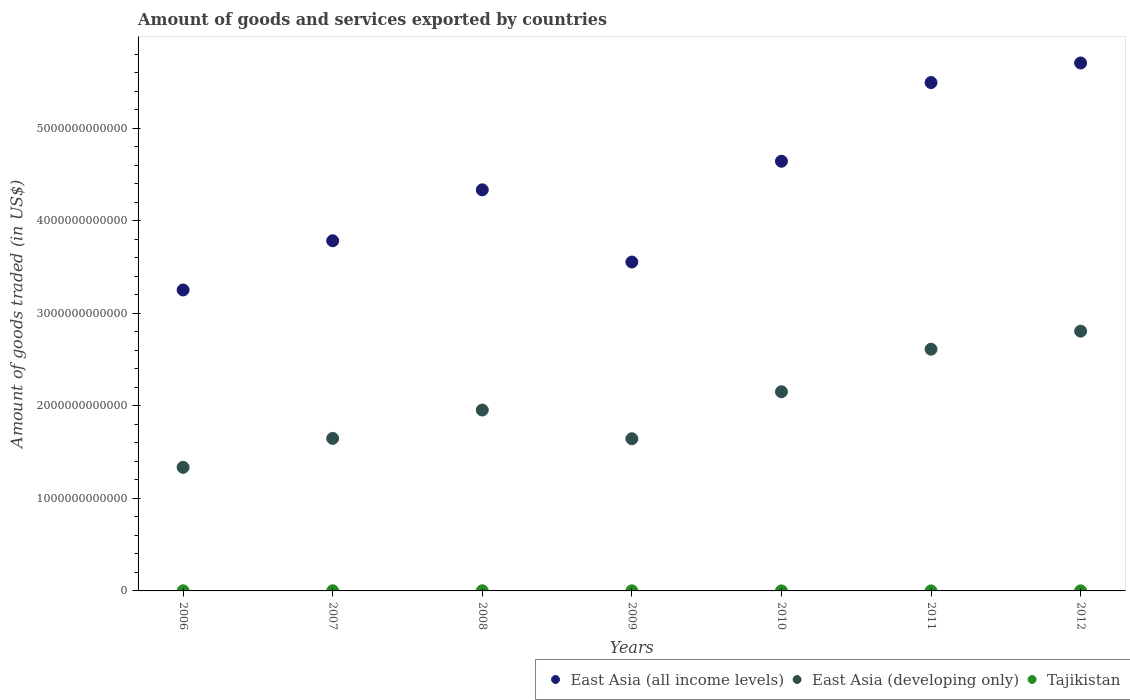What is the total amount of goods and services exported in Tajikistan in 2006?
Your answer should be very brief. 1.51e+09. Across all years, what is the maximum total amount of goods and services exported in East Asia (developing only)?
Offer a terse response. 2.81e+12. Across all years, what is the minimum total amount of goods and services exported in East Asia (developing only)?
Give a very brief answer. 1.34e+12. In which year was the total amount of goods and services exported in Tajikistan maximum?
Offer a very short reply. 2008. What is the total total amount of goods and services exported in East Asia (all income levels) in the graph?
Your response must be concise. 3.08e+13. What is the difference between the total amount of goods and services exported in Tajikistan in 2007 and that in 2012?
Keep it short and to the point. 7.31e+08. What is the difference between the total amount of goods and services exported in East Asia (all income levels) in 2006 and the total amount of goods and services exported in East Asia (developing only) in 2009?
Keep it short and to the point. 1.61e+12. What is the average total amount of goods and services exported in Tajikistan per year?
Your answer should be compact. 1.08e+09. In the year 2007, what is the difference between the total amount of goods and services exported in East Asia (developing only) and total amount of goods and services exported in Tajikistan?
Keep it short and to the point. 1.65e+12. In how many years, is the total amount of goods and services exported in East Asia (all income levels) greater than 5200000000000 US$?
Provide a succinct answer. 2. What is the ratio of the total amount of goods and services exported in East Asia (developing only) in 2008 to that in 2012?
Provide a succinct answer. 0.7. What is the difference between the highest and the second highest total amount of goods and services exported in Tajikistan?
Your response must be concise. 1.80e+07. What is the difference between the highest and the lowest total amount of goods and services exported in East Asia (all income levels)?
Offer a very short reply. 2.45e+12. Is the total amount of goods and services exported in East Asia (all income levels) strictly less than the total amount of goods and services exported in East Asia (developing only) over the years?
Keep it short and to the point. No. How many dotlines are there?
Your answer should be very brief. 3. How many years are there in the graph?
Your response must be concise. 7. What is the difference between two consecutive major ticks on the Y-axis?
Make the answer very short. 1.00e+12. Are the values on the major ticks of Y-axis written in scientific E-notation?
Your response must be concise. No. Does the graph contain any zero values?
Your answer should be very brief. No. Where does the legend appear in the graph?
Ensure brevity in your answer.  Bottom right. How are the legend labels stacked?
Offer a very short reply. Horizontal. What is the title of the graph?
Your answer should be compact. Amount of goods and services exported by countries. What is the label or title of the X-axis?
Offer a very short reply. Years. What is the label or title of the Y-axis?
Your answer should be very brief. Amount of goods traded (in US$). What is the Amount of goods traded (in US$) of East Asia (all income levels) in 2006?
Your answer should be compact. 3.25e+12. What is the Amount of goods traded (in US$) in East Asia (developing only) in 2006?
Ensure brevity in your answer.  1.34e+12. What is the Amount of goods traded (in US$) of Tajikistan in 2006?
Your response must be concise. 1.51e+09. What is the Amount of goods traded (in US$) of East Asia (all income levels) in 2007?
Your response must be concise. 3.78e+12. What is the Amount of goods traded (in US$) in East Asia (developing only) in 2007?
Ensure brevity in your answer.  1.65e+12. What is the Amount of goods traded (in US$) in Tajikistan in 2007?
Offer a terse response. 1.56e+09. What is the Amount of goods traded (in US$) in East Asia (all income levels) in 2008?
Your answer should be compact. 4.33e+12. What is the Amount of goods traded (in US$) of East Asia (developing only) in 2008?
Provide a succinct answer. 1.95e+12. What is the Amount of goods traded (in US$) of Tajikistan in 2008?
Keep it short and to the point. 1.57e+09. What is the Amount of goods traded (in US$) in East Asia (all income levels) in 2009?
Offer a very short reply. 3.55e+12. What is the Amount of goods traded (in US$) of East Asia (developing only) in 2009?
Your response must be concise. 1.64e+12. What is the Amount of goods traded (in US$) of Tajikistan in 2009?
Offer a very short reply. 1.04e+09. What is the Amount of goods traded (in US$) in East Asia (all income levels) in 2010?
Give a very brief answer. 4.64e+12. What is the Amount of goods traded (in US$) of East Asia (developing only) in 2010?
Offer a very short reply. 2.15e+12. What is the Amount of goods traded (in US$) in Tajikistan in 2010?
Keep it short and to the point. 4.59e+08. What is the Amount of goods traded (in US$) in East Asia (all income levels) in 2011?
Provide a succinct answer. 5.49e+12. What is the Amount of goods traded (in US$) in East Asia (developing only) in 2011?
Ensure brevity in your answer.  2.61e+12. What is the Amount of goods traded (in US$) of Tajikistan in 2011?
Make the answer very short. 5.93e+08. What is the Amount of goods traded (in US$) in East Asia (all income levels) in 2012?
Offer a very short reply. 5.70e+12. What is the Amount of goods traded (in US$) of East Asia (developing only) in 2012?
Ensure brevity in your answer.  2.81e+12. What is the Amount of goods traded (in US$) of Tajikistan in 2012?
Your answer should be compact. 8.26e+08. Across all years, what is the maximum Amount of goods traded (in US$) of East Asia (all income levels)?
Offer a terse response. 5.70e+12. Across all years, what is the maximum Amount of goods traded (in US$) in East Asia (developing only)?
Make the answer very short. 2.81e+12. Across all years, what is the maximum Amount of goods traded (in US$) of Tajikistan?
Ensure brevity in your answer.  1.57e+09. Across all years, what is the minimum Amount of goods traded (in US$) of East Asia (all income levels)?
Offer a very short reply. 3.25e+12. Across all years, what is the minimum Amount of goods traded (in US$) in East Asia (developing only)?
Make the answer very short. 1.34e+12. Across all years, what is the minimum Amount of goods traded (in US$) in Tajikistan?
Your answer should be very brief. 4.59e+08. What is the total Amount of goods traded (in US$) in East Asia (all income levels) in the graph?
Your response must be concise. 3.08e+13. What is the total Amount of goods traded (in US$) of East Asia (developing only) in the graph?
Provide a succinct answer. 1.42e+13. What is the total Amount of goods traded (in US$) in Tajikistan in the graph?
Give a very brief answer. 7.56e+09. What is the difference between the Amount of goods traded (in US$) of East Asia (all income levels) in 2006 and that in 2007?
Your response must be concise. -5.32e+11. What is the difference between the Amount of goods traded (in US$) of East Asia (developing only) in 2006 and that in 2007?
Offer a terse response. -3.13e+11. What is the difference between the Amount of goods traded (in US$) in Tajikistan in 2006 and that in 2007?
Provide a succinct answer. -4.51e+07. What is the difference between the Amount of goods traded (in US$) in East Asia (all income levels) in 2006 and that in 2008?
Your answer should be compact. -1.08e+12. What is the difference between the Amount of goods traded (in US$) of East Asia (developing only) in 2006 and that in 2008?
Your answer should be compact. -6.19e+11. What is the difference between the Amount of goods traded (in US$) in Tajikistan in 2006 and that in 2008?
Offer a terse response. -6.31e+07. What is the difference between the Amount of goods traded (in US$) in East Asia (all income levels) in 2006 and that in 2009?
Ensure brevity in your answer.  -3.02e+11. What is the difference between the Amount of goods traded (in US$) in East Asia (developing only) in 2006 and that in 2009?
Ensure brevity in your answer.  -3.09e+11. What is the difference between the Amount of goods traded (in US$) of Tajikistan in 2006 and that in 2009?
Ensure brevity in your answer.  4.73e+08. What is the difference between the Amount of goods traded (in US$) of East Asia (all income levels) in 2006 and that in 2010?
Offer a very short reply. -1.39e+12. What is the difference between the Amount of goods traded (in US$) of East Asia (developing only) in 2006 and that in 2010?
Keep it short and to the point. -8.17e+11. What is the difference between the Amount of goods traded (in US$) of Tajikistan in 2006 and that in 2010?
Keep it short and to the point. 1.05e+09. What is the difference between the Amount of goods traded (in US$) of East Asia (all income levels) in 2006 and that in 2011?
Give a very brief answer. -2.24e+12. What is the difference between the Amount of goods traded (in US$) in East Asia (developing only) in 2006 and that in 2011?
Provide a succinct answer. -1.28e+12. What is the difference between the Amount of goods traded (in US$) in Tajikistan in 2006 and that in 2011?
Offer a terse response. 9.18e+08. What is the difference between the Amount of goods traded (in US$) in East Asia (all income levels) in 2006 and that in 2012?
Give a very brief answer. -2.45e+12. What is the difference between the Amount of goods traded (in US$) of East Asia (developing only) in 2006 and that in 2012?
Make the answer very short. -1.47e+12. What is the difference between the Amount of goods traded (in US$) in Tajikistan in 2006 and that in 2012?
Ensure brevity in your answer.  6.86e+08. What is the difference between the Amount of goods traded (in US$) in East Asia (all income levels) in 2007 and that in 2008?
Your answer should be compact. -5.50e+11. What is the difference between the Amount of goods traded (in US$) of East Asia (developing only) in 2007 and that in 2008?
Give a very brief answer. -3.07e+11. What is the difference between the Amount of goods traded (in US$) in Tajikistan in 2007 and that in 2008?
Ensure brevity in your answer.  -1.80e+07. What is the difference between the Amount of goods traded (in US$) of East Asia (all income levels) in 2007 and that in 2009?
Your response must be concise. 2.30e+11. What is the difference between the Amount of goods traded (in US$) in East Asia (developing only) in 2007 and that in 2009?
Keep it short and to the point. 3.78e+09. What is the difference between the Amount of goods traded (in US$) of Tajikistan in 2007 and that in 2009?
Ensure brevity in your answer.  5.18e+08. What is the difference between the Amount of goods traded (in US$) of East Asia (all income levels) in 2007 and that in 2010?
Ensure brevity in your answer.  -8.59e+11. What is the difference between the Amount of goods traded (in US$) of East Asia (developing only) in 2007 and that in 2010?
Your answer should be very brief. -5.04e+11. What is the difference between the Amount of goods traded (in US$) of Tajikistan in 2007 and that in 2010?
Ensure brevity in your answer.  1.10e+09. What is the difference between the Amount of goods traded (in US$) of East Asia (all income levels) in 2007 and that in 2011?
Your answer should be very brief. -1.71e+12. What is the difference between the Amount of goods traded (in US$) of East Asia (developing only) in 2007 and that in 2011?
Your answer should be compact. -9.64e+11. What is the difference between the Amount of goods traded (in US$) in Tajikistan in 2007 and that in 2011?
Give a very brief answer. 9.64e+08. What is the difference between the Amount of goods traded (in US$) of East Asia (all income levels) in 2007 and that in 2012?
Give a very brief answer. -1.92e+12. What is the difference between the Amount of goods traded (in US$) of East Asia (developing only) in 2007 and that in 2012?
Offer a very short reply. -1.16e+12. What is the difference between the Amount of goods traded (in US$) in Tajikistan in 2007 and that in 2012?
Offer a very short reply. 7.31e+08. What is the difference between the Amount of goods traded (in US$) in East Asia (all income levels) in 2008 and that in 2009?
Keep it short and to the point. 7.80e+11. What is the difference between the Amount of goods traded (in US$) in East Asia (developing only) in 2008 and that in 2009?
Provide a succinct answer. 3.10e+11. What is the difference between the Amount of goods traded (in US$) in Tajikistan in 2008 and that in 2009?
Keep it short and to the point. 5.36e+08. What is the difference between the Amount of goods traded (in US$) in East Asia (all income levels) in 2008 and that in 2010?
Provide a short and direct response. -3.09e+11. What is the difference between the Amount of goods traded (in US$) in East Asia (developing only) in 2008 and that in 2010?
Offer a terse response. -1.98e+11. What is the difference between the Amount of goods traded (in US$) of Tajikistan in 2008 and that in 2010?
Give a very brief answer. 1.12e+09. What is the difference between the Amount of goods traded (in US$) of East Asia (all income levels) in 2008 and that in 2011?
Provide a short and direct response. -1.16e+12. What is the difference between the Amount of goods traded (in US$) of East Asia (developing only) in 2008 and that in 2011?
Keep it short and to the point. -6.57e+11. What is the difference between the Amount of goods traded (in US$) of Tajikistan in 2008 and that in 2011?
Ensure brevity in your answer.  9.82e+08. What is the difference between the Amount of goods traded (in US$) of East Asia (all income levels) in 2008 and that in 2012?
Make the answer very short. -1.37e+12. What is the difference between the Amount of goods traded (in US$) of East Asia (developing only) in 2008 and that in 2012?
Ensure brevity in your answer.  -8.52e+11. What is the difference between the Amount of goods traded (in US$) of Tajikistan in 2008 and that in 2012?
Your answer should be compact. 7.49e+08. What is the difference between the Amount of goods traded (in US$) of East Asia (all income levels) in 2009 and that in 2010?
Keep it short and to the point. -1.09e+12. What is the difference between the Amount of goods traded (in US$) in East Asia (developing only) in 2009 and that in 2010?
Make the answer very short. -5.08e+11. What is the difference between the Amount of goods traded (in US$) of Tajikistan in 2009 and that in 2010?
Offer a very short reply. 5.79e+08. What is the difference between the Amount of goods traded (in US$) of East Asia (all income levels) in 2009 and that in 2011?
Keep it short and to the point. -1.94e+12. What is the difference between the Amount of goods traded (in US$) in East Asia (developing only) in 2009 and that in 2011?
Make the answer very short. -9.68e+11. What is the difference between the Amount of goods traded (in US$) of Tajikistan in 2009 and that in 2011?
Your response must be concise. 4.45e+08. What is the difference between the Amount of goods traded (in US$) of East Asia (all income levels) in 2009 and that in 2012?
Offer a very short reply. -2.15e+12. What is the difference between the Amount of goods traded (in US$) of East Asia (developing only) in 2009 and that in 2012?
Offer a very short reply. -1.16e+12. What is the difference between the Amount of goods traded (in US$) in Tajikistan in 2009 and that in 2012?
Provide a succinct answer. 2.13e+08. What is the difference between the Amount of goods traded (in US$) in East Asia (all income levels) in 2010 and that in 2011?
Make the answer very short. -8.50e+11. What is the difference between the Amount of goods traded (in US$) of East Asia (developing only) in 2010 and that in 2011?
Your answer should be very brief. -4.60e+11. What is the difference between the Amount of goods traded (in US$) of Tajikistan in 2010 and that in 2011?
Offer a very short reply. -1.34e+08. What is the difference between the Amount of goods traded (in US$) in East Asia (all income levels) in 2010 and that in 2012?
Your answer should be compact. -1.06e+12. What is the difference between the Amount of goods traded (in US$) in East Asia (developing only) in 2010 and that in 2012?
Provide a succinct answer. -6.55e+11. What is the difference between the Amount of goods traded (in US$) of Tajikistan in 2010 and that in 2012?
Ensure brevity in your answer.  -3.67e+08. What is the difference between the Amount of goods traded (in US$) of East Asia (all income levels) in 2011 and that in 2012?
Your answer should be compact. -2.12e+11. What is the difference between the Amount of goods traded (in US$) in East Asia (developing only) in 2011 and that in 2012?
Give a very brief answer. -1.95e+11. What is the difference between the Amount of goods traded (in US$) in Tajikistan in 2011 and that in 2012?
Offer a terse response. -2.33e+08. What is the difference between the Amount of goods traded (in US$) in East Asia (all income levels) in 2006 and the Amount of goods traded (in US$) in East Asia (developing only) in 2007?
Your response must be concise. 1.60e+12. What is the difference between the Amount of goods traded (in US$) in East Asia (all income levels) in 2006 and the Amount of goods traded (in US$) in Tajikistan in 2007?
Keep it short and to the point. 3.25e+12. What is the difference between the Amount of goods traded (in US$) in East Asia (developing only) in 2006 and the Amount of goods traded (in US$) in Tajikistan in 2007?
Ensure brevity in your answer.  1.33e+12. What is the difference between the Amount of goods traded (in US$) in East Asia (all income levels) in 2006 and the Amount of goods traded (in US$) in East Asia (developing only) in 2008?
Offer a terse response. 1.30e+12. What is the difference between the Amount of goods traded (in US$) of East Asia (all income levels) in 2006 and the Amount of goods traded (in US$) of Tajikistan in 2008?
Offer a very short reply. 3.25e+12. What is the difference between the Amount of goods traded (in US$) in East Asia (developing only) in 2006 and the Amount of goods traded (in US$) in Tajikistan in 2008?
Offer a very short reply. 1.33e+12. What is the difference between the Amount of goods traded (in US$) of East Asia (all income levels) in 2006 and the Amount of goods traded (in US$) of East Asia (developing only) in 2009?
Your answer should be very brief. 1.61e+12. What is the difference between the Amount of goods traded (in US$) of East Asia (all income levels) in 2006 and the Amount of goods traded (in US$) of Tajikistan in 2009?
Make the answer very short. 3.25e+12. What is the difference between the Amount of goods traded (in US$) in East Asia (developing only) in 2006 and the Amount of goods traded (in US$) in Tajikistan in 2009?
Make the answer very short. 1.33e+12. What is the difference between the Amount of goods traded (in US$) of East Asia (all income levels) in 2006 and the Amount of goods traded (in US$) of East Asia (developing only) in 2010?
Provide a succinct answer. 1.10e+12. What is the difference between the Amount of goods traded (in US$) in East Asia (all income levels) in 2006 and the Amount of goods traded (in US$) in Tajikistan in 2010?
Make the answer very short. 3.25e+12. What is the difference between the Amount of goods traded (in US$) of East Asia (developing only) in 2006 and the Amount of goods traded (in US$) of Tajikistan in 2010?
Keep it short and to the point. 1.33e+12. What is the difference between the Amount of goods traded (in US$) in East Asia (all income levels) in 2006 and the Amount of goods traded (in US$) in East Asia (developing only) in 2011?
Provide a succinct answer. 6.40e+11. What is the difference between the Amount of goods traded (in US$) in East Asia (all income levels) in 2006 and the Amount of goods traded (in US$) in Tajikistan in 2011?
Your answer should be very brief. 3.25e+12. What is the difference between the Amount of goods traded (in US$) in East Asia (developing only) in 2006 and the Amount of goods traded (in US$) in Tajikistan in 2011?
Offer a very short reply. 1.33e+12. What is the difference between the Amount of goods traded (in US$) of East Asia (all income levels) in 2006 and the Amount of goods traded (in US$) of East Asia (developing only) in 2012?
Your answer should be very brief. 4.45e+11. What is the difference between the Amount of goods traded (in US$) in East Asia (all income levels) in 2006 and the Amount of goods traded (in US$) in Tajikistan in 2012?
Ensure brevity in your answer.  3.25e+12. What is the difference between the Amount of goods traded (in US$) of East Asia (developing only) in 2006 and the Amount of goods traded (in US$) of Tajikistan in 2012?
Your response must be concise. 1.33e+12. What is the difference between the Amount of goods traded (in US$) in East Asia (all income levels) in 2007 and the Amount of goods traded (in US$) in East Asia (developing only) in 2008?
Your answer should be compact. 1.83e+12. What is the difference between the Amount of goods traded (in US$) of East Asia (all income levels) in 2007 and the Amount of goods traded (in US$) of Tajikistan in 2008?
Keep it short and to the point. 3.78e+12. What is the difference between the Amount of goods traded (in US$) of East Asia (developing only) in 2007 and the Amount of goods traded (in US$) of Tajikistan in 2008?
Ensure brevity in your answer.  1.65e+12. What is the difference between the Amount of goods traded (in US$) of East Asia (all income levels) in 2007 and the Amount of goods traded (in US$) of East Asia (developing only) in 2009?
Make the answer very short. 2.14e+12. What is the difference between the Amount of goods traded (in US$) of East Asia (all income levels) in 2007 and the Amount of goods traded (in US$) of Tajikistan in 2009?
Offer a very short reply. 3.78e+12. What is the difference between the Amount of goods traded (in US$) in East Asia (developing only) in 2007 and the Amount of goods traded (in US$) in Tajikistan in 2009?
Provide a succinct answer. 1.65e+12. What is the difference between the Amount of goods traded (in US$) of East Asia (all income levels) in 2007 and the Amount of goods traded (in US$) of East Asia (developing only) in 2010?
Offer a very short reply. 1.63e+12. What is the difference between the Amount of goods traded (in US$) of East Asia (all income levels) in 2007 and the Amount of goods traded (in US$) of Tajikistan in 2010?
Keep it short and to the point. 3.78e+12. What is the difference between the Amount of goods traded (in US$) of East Asia (developing only) in 2007 and the Amount of goods traded (in US$) of Tajikistan in 2010?
Provide a short and direct response. 1.65e+12. What is the difference between the Amount of goods traded (in US$) of East Asia (all income levels) in 2007 and the Amount of goods traded (in US$) of East Asia (developing only) in 2011?
Your response must be concise. 1.17e+12. What is the difference between the Amount of goods traded (in US$) in East Asia (all income levels) in 2007 and the Amount of goods traded (in US$) in Tajikistan in 2011?
Give a very brief answer. 3.78e+12. What is the difference between the Amount of goods traded (in US$) in East Asia (developing only) in 2007 and the Amount of goods traded (in US$) in Tajikistan in 2011?
Your answer should be compact. 1.65e+12. What is the difference between the Amount of goods traded (in US$) of East Asia (all income levels) in 2007 and the Amount of goods traded (in US$) of East Asia (developing only) in 2012?
Your answer should be very brief. 9.77e+11. What is the difference between the Amount of goods traded (in US$) in East Asia (all income levels) in 2007 and the Amount of goods traded (in US$) in Tajikistan in 2012?
Give a very brief answer. 3.78e+12. What is the difference between the Amount of goods traded (in US$) in East Asia (developing only) in 2007 and the Amount of goods traded (in US$) in Tajikistan in 2012?
Your answer should be very brief. 1.65e+12. What is the difference between the Amount of goods traded (in US$) of East Asia (all income levels) in 2008 and the Amount of goods traded (in US$) of East Asia (developing only) in 2009?
Your response must be concise. 2.69e+12. What is the difference between the Amount of goods traded (in US$) in East Asia (all income levels) in 2008 and the Amount of goods traded (in US$) in Tajikistan in 2009?
Provide a succinct answer. 4.33e+12. What is the difference between the Amount of goods traded (in US$) of East Asia (developing only) in 2008 and the Amount of goods traded (in US$) of Tajikistan in 2009?
Give a very brief answer. 1.95e+12. What is the difference between the Amount of goods traded (in US$) in East Asia (all income levels) in 2008 and the Amount of goods traded (in US$) in East Asia (developing only) in 2010?
Ensure brevity in your answer.  2.18e+12. What is the difference between the Amount of goods traded (in US$) of East Asia (all income levels) in 2008 and the Amount of goods traded (in US$) of Tajikistan in 2010?
Give a very brief answer. 4.33e+12. What is the difference between the Amount of goods traded (in US$) of East Asia (developing only) in 2008 and the Amount of goods traded (in US$) of Tajikistan in 2010?
Make the answer very short. 1.95e+12. What is the difference between the Amount of goods traded (in US$) of East Asia (all income levels) in 2008 and the Amount of goods traded (in US$) of East Asia (developing only) in 2011?
Provide a succinct answer. 1.72e+12. What is the difference between the Amount of goods traded (in US$) of East Asia (all income levels) in 2008 and the Amount of goods traded (in US$) of Tajikistan in 2011?
Provide a succinct answer. 4.33e+12. What is the difference between the Amount of goods traded (in US$) in East Asia (developing only) in 2008 and the Amount of goods traded (in US$) in Tajikistan in 2011?
Keep it short and to the point. 1.95e+12. What is the difference between the Amount of goods traded (in US$) of East Asia (all income levels) in 2008 and the Amount of goods traded (in US$) of East Asia (developing only) in 2012?
Your response must be concise. 1.53e+12. What is the difference between the Amount of goods traded (in US$) in East Asia (all income levels) in 2008 and the Amount of goods traded (in US$) in Tajikistan in 2012?
Keep it short and to the point. 4.33e+12. What is the difference between the Amount of goods traded (in US$) in East Asia (developing only) in 2008 and the Amount of goods traded (in US$) in Tajikistan in 2012?
Your response must be concise. 1.95e+12. What is the difference between the Amount of goods traded (in US$) of East Asia (all income levels) in 2009 and the Amount of goods traded (in US$) of East Asia (developing only) in 2010?
Offer a very short reply. 1.40e+12. What is the difference between the Amount of goods traded (in US$) in East Asia (all income levels) in 2009 and the Amount of goods traded (in US$) in Tajikistan in 2010?
Ensure brevity in your answer.  3.55e+12. What is the difference between the Amount of goods traded (in US$) in East Asia (developing only) in 2009 and the Amount of goods traded (in US$) in Tajikistan in 2010?
Keep it short and to the point. 1.64e+12. What is the difference between the Amount of goods traded (in US$) in East Asia (all income levels) in 2009 and the Amount of goods traded (in US$) in East Asia (developing only) in 2011?
Keep it short and to the point. 9.42e+11. What is the difference between the Amount of goods traded (in US$) in East Asia (all income levels) in 2009 and the Amount of goods traded (in US$) in Tajikistan in 2011?
Keep it short and to the point. 3.55e+12. What is the difference between the Amount of goods traded (in US$) in East Asia (developing only) in 2009 and the Amount of goods traded (in US$) in Tajikistan in 2011?
Your response must be concise. 1.64e+12. What is the difference between the Amount of goods traded (in US$) in East Asia (all income levels) in 2009 and the Amount of goods traded (in US$) in East Asia (developing only) in 2012?
Your response must be concise. 7.47e+11. What is the difference between the Amount of goods traded (in US$) in East Asia (all income levels) in 2009 and the Amount of goods traded (in US$) in Tajikistan in 2012?
Provide a succinct answer. 3.55e+12. What is the difference between the Amount of goods traded (in US$) in East Asia (developing only) in 2009 and the Amount of goods traded (in US$) in Tajikistan in 2012?
Ensure brevity in your answer.  1.64e+12. What is the difference between the Amount of goods traded (in US$) in East Asia (all income levels) in 2010 and the Amount of goods traded (in US$) in East Asia (developing only) in 2011?
Give a very brief answer. 2.03e+12. What is the difference between the Amount of goods traded (in US$) in East Asia (all income levels) in 2010 and the Amount of goods traded (in US$) in Tajikistan in 2011?
Ensure brevity in your answer.  4.64e+12. What is the difference between the Amount of goods traded (in US$) in East Asia (developing only) in 2010 and the Amount of goods traded (in US$) in Tajikistan in 2011?
Your answer should be very brief. 2.15e+12. What is the difference between the Amount of goods traded (in US$) of East Asia (all income levels) in 2010 and the Amount of goods traded (in US$) of East Asia (developing only) in 2012?
Your answer should be very brief. 1.84e+12. What is the difference between the Amount of goods traded (in US$) of East Asia (all income levels) in 2010 and the Amount of goods traded (in US$) of Tajikistan in 2012?
Offer a very short reply. 4.64e+12. What is the difference between the Amount of goods traded (in US$) in East Asia (developing only) in 2010 and the Amount of goods traded (in US$) in Tajikistan in 2012?
Keep it short and to the point. 2.15e+12. What is the difference between the Amount of goods traded (in US$) of East Asia (all income levels) in 2011 and the Amount of goods traded (in US$) of East Asia (developing only) in 2012?
Offer a very short reply. 2.69e+12. What is the difference between the Amount of goods traded (in US$) of East Asia (all income levels) in 2011 and the Amount of goods traded (in US$) of Tajikistan in 2012?
Provide a short and direct response. 5.49e+12. What is the difference between the Amount of goods traded (in US$) of East Asia (developing only) in 2011 and the Amount of goods traded (in US$) of Tajikistan in 2012?
Make the answer very short. 2.61e+12. What is the average Amount of goods traded (in US$) in East Asia (all income levels) per year?
Your answer should be very brief. 4.39e+12. What is the average Amount of goods traded (in US$) of East Asia (developing only) per year?
Make the answer very short. 2.02e+12. What is the average Amount of goods traded (in US$) of Tajikistan per year?
Provide a succinct answer. 1.08e+09. In the year 2006, what is the difference between the Amount of goods traded (in US$) in East Asia (all income levels) and Amount of goods traded (in US$) in East Asia (developing only)?
Offer a terse response. 1.92e+12. In the year 2006, what is the difference between the Amount of goods traded (in US$) in East Asia (all income levels) and Amount of goods traded (in US$) in Tajikistan?
Offer a terse response. 3.25e+12. In the year 2006, what is the difference between the Amount of goods traded (in US$) in East Asia (developing only) and Amount of goods traded (in US$) in Tajikistan?
Your answer should be very brief. 1.33e+12. In the year 2007, what is the difference between the Amount of goods traded (in US$) in East Asia (all income levels) and Amount of goods traded (in US$) in East Asia (developing only)?
Offer a terse response. 2.14e+12. In the year 2007, what is the difference between the Amount of goods traded (in US$) in East Asia (all income levels) and Amount of goods traded (in US$) in Tajikistan?
Keep it short and to the point. 3.78e+12. In the year 2007, what is the difference between the Amount of goods traded (in US$) in East Asia (developing only) and Amount of goods traded (in US$) in Tajikistan?
Provide a short and direct response. 1.65e+12. In the year 2008, what is the difference between the Amount of goods traded (in US$) in East Asia (all income levels) and Amount of goods traded (in US$) in East Asia (developing only)?
Your answer should be compact. 2.38e+12. In the year 2008, what is the difference between the Amount of goods traded (in US$) of East Asia (all income levels) and Amount of goods traded (in US$) of Tajikistan?
Provide a short and direct response. 4.33e+12. In the year 2008, what is the difference between the Amount of goods traded (in US$) in East Asia (developing only) and Amount of goods traded (in US$) in Tajikistan?
Your answer should be very brief. 1.95e+12. In the year 2009, what is the difference between the Amount of goods traded (in US$) in East Asia (all income levels) and Amount of goods traded (in US$) in East Asia (developing only)?
Keep it short and to the point. 1.91e+12. In the year 2009, what is the difference between the Amount of goods traded (in US$) in East Asia (all income levels) and Amount of goods traded (in US$) in Tajikistan?
Provide a short and direct response. 3.55e+12. In the year 2009, what is the difference between the Amount of goods traded (in US$) of East Asia (developing only) and Amount of goods traded (in US$) of Tajikistan?
Offer a terse response. 1.64e+12. In the year 2010, what is the difference between the Amount of goods traded (in US$) of East Asia (all income levels) and Amount of goods traded (in US$) of East Asia (developing only)?
Ensure brevity in your answer.  2.49e+12. In the year 2010, what is the difference between the Amount of goods traded (in US$) in East Asia (all income levels) and Amount of goods traded (in US$) in Tajikistan?
Provide a short and direct response. 4.64e+12. In the year 2010, what is the difference between the Amount of goods traded (in US$) of East Asia (developing only) and Amount of goods traded (in US$) of Tajikistan?
Provide a succinct answer. 2.15e+12. In the year 2011, what is the difference between the Amount of goods traded (in US$) of East Asia (all income levels) and Amount of goods traded (in US$) of East Asia (developing only)?
Offer a very short reply. 2.88e+12. In the year 2011, what is the difference between the Amount of goods traded (in US$) in East Asia (all income levels) and Amount of goods traded (in US$) in Tajikistan?
Make the answer very short. 5.49e+12. In the year 2011, what is the difference between the Amount of goods traded (in US$) in East Asia (developing only) and Amount of goods traded (in US$) in Tajikistan?
Offer a very short reply. 2.61e+12. In the year 2012, what is the difference between the Amount of goods traded (in US$) of East Asia (all income levels) and Amount of goods traded (in US$) of East Asia (developing only)?
Provide a succinct answer. 2.90e+12. In the year 2012, what is the difference between the Amount of goods traded (in US$) in East Asia (all income levels) and Amount of goods traded (in US$) in Tajikistan?
Offer a terse response. 5.70e+12. In the year 2012, what is the difference between the Amount of goods traded (in US$) of East Asia (developing only) and Amount of goods traded (in US$) of Tajikistan?
Offer a very short reply. 2.81e+12. What is the ratio of the Amount of goods traded (in US$) of East Asia (all income levels) in 2006 to that in 2007?
Give a very brief answer. 0.86. What is the ratio of the Amount of goods traded (in US$) in East Asia (developing only) in 2006 to that in 2007?
Give a very brief answer. 0.81. What is the ratio of the Amount of goods traded (in US$) in East Asia (all income levels) in 2006 to that in 2008?
Offer a very short reply. 0.75. What is the ratio of the Amount of goods traded (in US$) of East Asia (developing only) in 2006 to that in 2008?
Ensure brevity in your answer.  0.68. What is the ratio of the Amount of goods traded (in US$) of Tajikistan in 2006 to that in 2008?
Offer a very short reply. 0.96. What is the ratio of the Amount of goods traded (in US$) of East Asia (all income levels) in 2006 to that in 2009?
Provide a short and direct response. 0.92. What is the ratio of the Amount of goods traded (in US$) in East Asia (developing only) in 2006 to that in 2009?
Keep it short and to the point. 0.81. What is the ratio of the Amount of goods traded (in US$) of Tajikistan in 2006 to that in 2009?
Ensure brevity in your answer.  1.46. What is the ratio of the Amount of goods traded (in US$) of East Asia (all income levels) in 2006 to that in 2010?
Your response must be concise. 0.7. What is the ratio of the Amount of goods traded (in US$) of East Asia (developing only) in 2006 to that in 2010?
Provide a succinct answer. 0.62. What is the ratio of the Amount of goods traded (in US$) in Tajikistan in 2006 to that in 2010?
Make the answer very short. 3.29. What is the ratio of the Amount of goods traded (in US$) of East Asia (all income levels) in 2006 to that in 2011?
Your answer should be compact. 0.59. What is the ratio of the Amount of goods traded (in US$) in East Asia (developing only) in 2006 to that in 2011?
Make the answer very short. 0.51. What is the ratio of the Amount of goods traded (in US$) of Tajikistan in 2006 to that in 2011?
Give a very brief answer. 2.55. What is the ratio of the Amount of goods traded (in US$) of East Asia (all income levels) in 2006 to that in 2012?
Ensure brevity in your answer.  0.57. What is the ratio of the Amount of goods traded (in US$) in East Asia (developing only) in 2006 to that in 2012?
Ensure brevity in your answer.  0.48. What is the ratio of the Amount of goods traded (in US$) in Tajikistan in 2006 to that in 2012?
Your answer should be very brief. 1.83. What is the ratio of the Amount of goods traded (in US$) in East Asia (all income levels) in 2007 to that in 2008?
Provide a succinct answer. 0.87. What is the ratio of the Amount of goods traded (in US$) of East Asia (developing only) in 2007 to that in 2008?
Offer a terse response. 0.84. What is the ratio of the Amount of goods traded (in US$) in East Asia (all income levels) in 2007 to that in 2009?
Your answer should be compact. 1.06. What is the ratio of the Amount of goods traded (in US$) of East Asia (developing only) in 2007 to that in 2009?
Offer a very short reply. 1. What is the ratio of the Amount of goods traded (in US$) of Tajikistan in 2007 to that in 2009?
Your answer should be very brief. 1.5. What is the ratio of the Amount of goods traded (in US$) of East Asia (all income levels) in 2007 to that in 2010?
Offer a very short reply. 0.81. What is the ratio of the Amount of goods traded (in US$) in East Asia (developing only) in 2007 to that in 2010?
Ensure brevity in your answer.  0.77. What is the ratio of the Amount of goods traded (in US$) in Tajikistan in 2007 to that in 2010?
Offer a terse response. 3.39. What is the ratio of the Amount of goods traded (in US$) in East Asia (all income levels) in 2007 to that in 2011?
Make the answer very short. 0.69. What is the ratio of the Amount of goods traded (in US$) in East Asia (developing only) in 2007 to that in 2011?
Your answer should be very brief. 0.63. What is the ratio of the Amount of goods traded (in US$) of Tajikistan in 2007 to that in 2011?
Your response must be concise. 2.62. What is the ratio of the Amount of goods traded (in US$) of East Asia (all income levels) in 2007 to that in 2012?
Offer a terse response. 0.66. What is the ratio of the Amount of goods traded (in US$) of East Asia (developing only) in 2007 to that in 2012?
Offer a very short reply. 0.59. What is the ratio of the Amount of goods traded (in US$) in Tajikistan in 2007 to that in 2012?
Provide a succinct answer. 1.89. What is the ratio of the Amount of goods traded (in US$) of East Asia (all income levels) in 2008 to that in 2009?
Your answer should be compact. 1.22. What is the ratio of the Amount of goods traded (in US$) of East Asia (developing only) in 2008 to that in 2009?
Ensure brevity in your answer.  1.19. What is the ratio of the Amount of goods traded (in US$) of Tajikistan in 2008 to that in 2009?
Give a very brief answer. 1.52. What is the ratio of the Amount of goods traded (in US$) of East Asia (all income levels) in 2008 to that in 2010?
Provide a succinct answer. 0.93. What is the ratio of the Amount of goods traded (in US$) of East Asia (developing only) in 2008 to that in 2010?
Your response must be concise. 0.91. What is the ratio of the Amount of goods traded (in US$) in Tajikistan in 2008 to that in 2010?
Ensure brevity in your answer.  3.43. What is the ratio of the Amount of goods traded (in US$) in East Asia (all income levels) in 2008 to that in 2011?
Ensure brevity in your answer.  0.79. What is the ratio of the Amount of goods traded (in US$) of East Asia (developing only) in 2008 to that in 2011?
Your answer should be compact. 0.75. What is the ratio of the Amount of goods traded (in US$) of Tajikistan in 2008 to that in 2011?
Keep it short and to the point. 2.65. What is the ratio of the Amount of goods traded (in US$) of East Asia (all income levels) in 2008 to that in 2012?
Offer a terse response. 0.76. What is the ratio of the Amount of goods traded (in US$) of East Asia (developing only) in 2008 to that in 2012?
Offer a terse response. 0.7. What is the ratio of the Amount of goods traded (in US$) of Tajikistan in 2008 to that in 2012?
Your response must be concise. 1.91. What is the ratio of the Amount of goods traded (in US$) of East Asia (all income levels) in 2009 to that in 2010?
Your answer should be very brief. 0.77. What is the ratio of the Amount of goods traded (in US$) in East Asia (developing only) in 2009 to that in 2010?
Keep it short and to the point. 0.76. What is the ratio of the Amount of goods traded (in US$) in Tajikistan in 2009 to that in 2010?
Provide a short and direct response. 2.26. What is the ratio of the Amount of goods traded (in US$) of East Asia (all income levels) in 2009 to that in 2011?
Your response must be concise. 0.65. What is the ratio of the Amount of goods traded (in US$) in East Asia (developing only) in 2009 to that in 2011?
Offer a terse response. 0.63. What is the ratio of the Amount of goods traded (in US$) in Tajikistan in 2009 to that in 2011?
Offer a very short reply. 1.75. What is the ratio of the Amount of goods traded (in US$) in East Asia (all income levels) in 2009 to that in 2012?
Provide a short and direct response. 0.62. What is the ratio of the Amount of goods traded (in US$) of East Asia (developing only) in 2009 to that in 2012?
Ensure brevity in your answer.  0.59. What is the ratio of the Amount of goods traded (in US$) of Tajikistan in 2009 to that in 2012?
Offer a terse response. 1.26. What is the ratio of the Amount of goods traded (in US$) in East Asia (all income levels) in 2010 to that in 2011?
Offer a very short reply. 0.85. What is the ratio of the Amount of goods traded (in US$) of East Asia (developing only) in 2010 to that in 2011?
Offer a terse response. 0.82. What is the ratio of the Amount of goods traded (in US$) of Tajikistan in 2010 to that in 2011?
Provide a succinct answer. 0.77. What is the ratio of the Amount of goods traded (in US$) of East Asia (all income levels) in 2010 to that in 2012?
Your answer should be compact. 0.81. What is the ratio of the Amount of goods traded (in US$) in East Asia (developing only) in 2010 to that in 2012?
Provide a short and direct response. 0.77. What is the ratio of the Amount of goods traded (in US$) of Tajikistan in 2010 to that in 2012?
Keep it short and to the point. 0.56. What is the ratio of the Amount of goods traded (in US$) of East Asia (all income levels) in 2011 to that in 2012?
Ensure brevity in your answer.  0.96. What is the ratio of the Amount of goods traded (in US$) of East Asia (developing only) in 2011 to that in 2012?
Your response must be concise. 0.93. What is the ratio of the Amount of goods traded (in US$) in Tajikistan in 2011 to that in 2012?
Ensure brevity in your answer.  0.72. What is the difference between the highest and the second highest Amount of goods traded (in US$) in East Asia (all income levels)?
Make the answer very short. 2.12e+11. What is the difference between the highest and the second highest Amount of goods traded (in US$) of East Asia (developing only)?
Make the answer very short. 1.95e+11. What is the difference between the highest and the second highest Amount of goods traded (in US$) of Tajikistan?
Your answer should be very brief. 1.80e+07. What is the difference between the highest and the lowest Amount of goods traded (in US$) in East Asia (all income levels)?
Your response must be concise. 2.45e+12. What is the difference between the highest and the lowest Amount of goods traded (in US$) of East Asia (developing only)?
Make the answer very short. 1.47e+12. What is the difference between the highest and the lowest Amount of goods traded (in US$) of Tajikistan?
Your answer should be compact. 1.12e+09. 